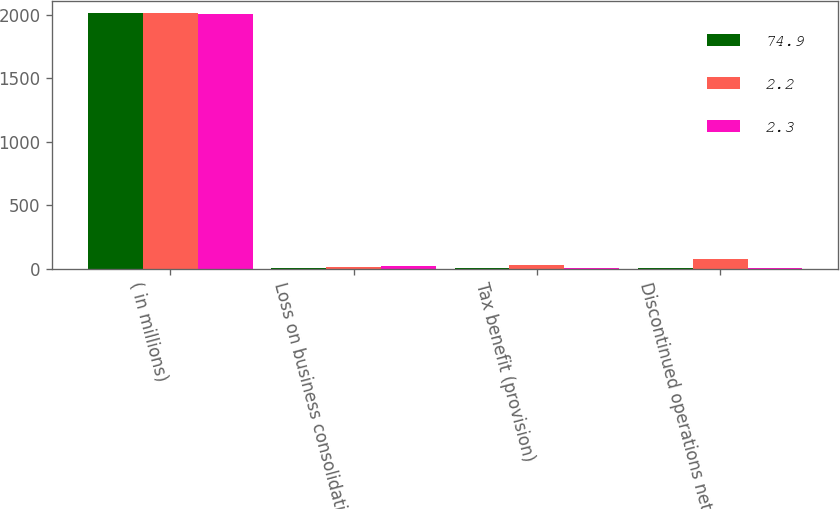<chart> <loc_0><loc_0><loc_500><loc_500><stacked_bar_chart><ecel><fcel>( in millions)<fcel>Loss on business consolidation<fcel>Tax benefit (provision)<fcel>Discontinued operations net of<nl><fcel>74.9<fcel>2011<fcel>3<fcel>1.5<fcel>2.3<nl><fcel>2.2<fcel>2010<fcel>10.4<fcel>30.5<fcel>74.9<nl><fcel>2.3<fcel>2009<fcel>23.1<fcel>3<fcel>2.2<nl></chart> 